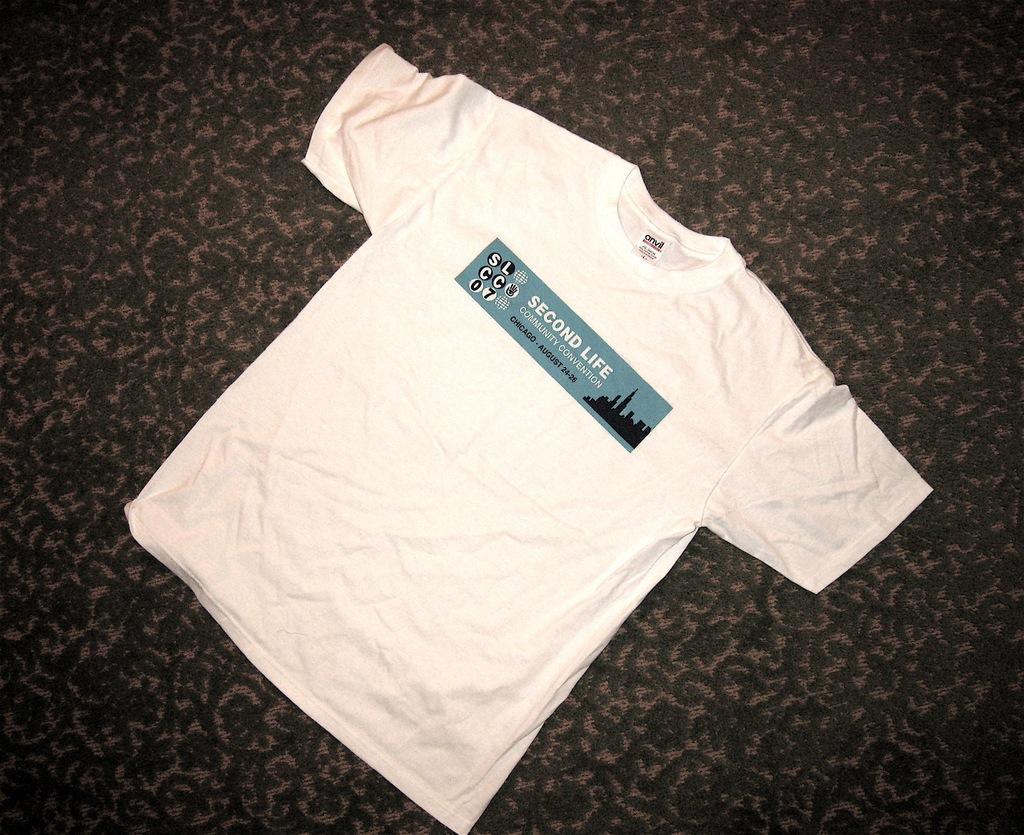What type of clothing item is visible in the image? There is a printed T-shirt in the image. Where is the T-shirt located in the image? The T-shirt is on a surface. What route does the truck take in the image? There is no truck present in the image, so it is not possible to determine the route it might take. 